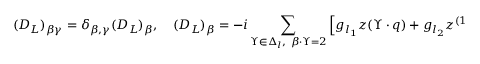Convert formula to latex. <formula><loc_0><loc_0><loc_500><loc_500>( D _ { L } ) _ { \beta \gamma } = \delta _ { \beta , \gamma } ( D _ { L } ) _ { \beta } , \quad ( D _ { L } ) _ { \beta } = - i \sum _ { \Upsilon \in \Delta _ { l } , \ \beta \cdot \Upsilon = 2 } \left [ g _ { l _ { 1 } } z ( \Upsilon \cdot q ) + g _ { l _ { 2 } } z ^ { ( 1 / 2 ) } ( \Upsilon \cdot q ) \right ] .</formula> 